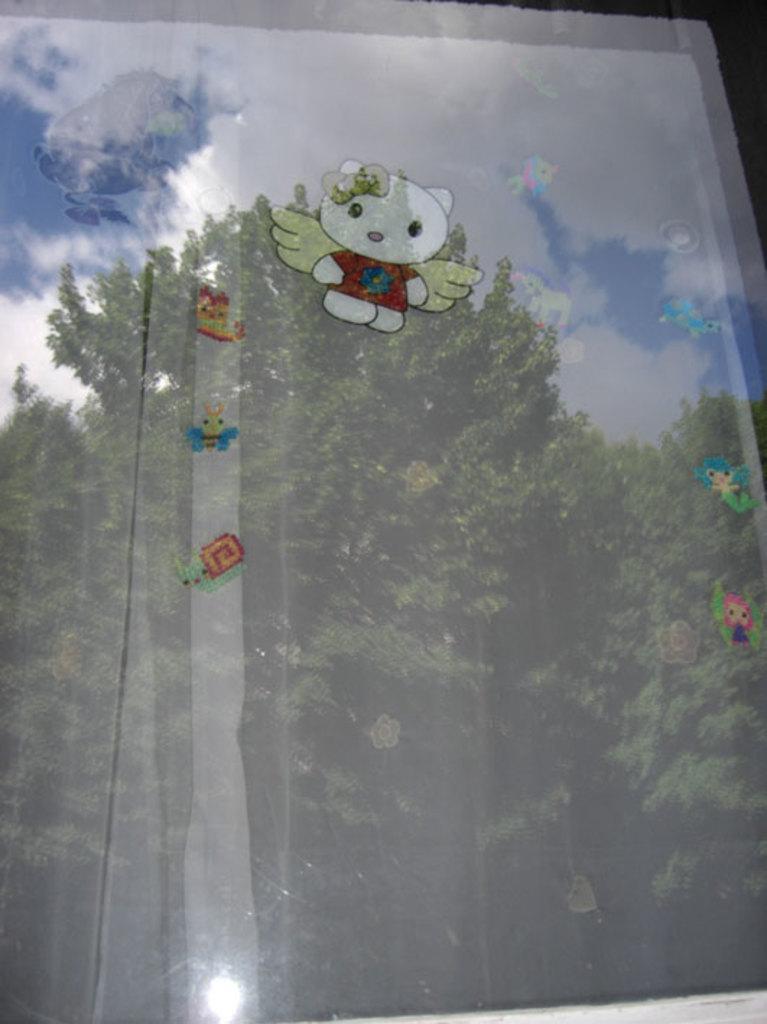Can you describe this image briefly? In the foreground of this image, there are few stickers on the glass. In the background, there are trees, sky and the cloud. 